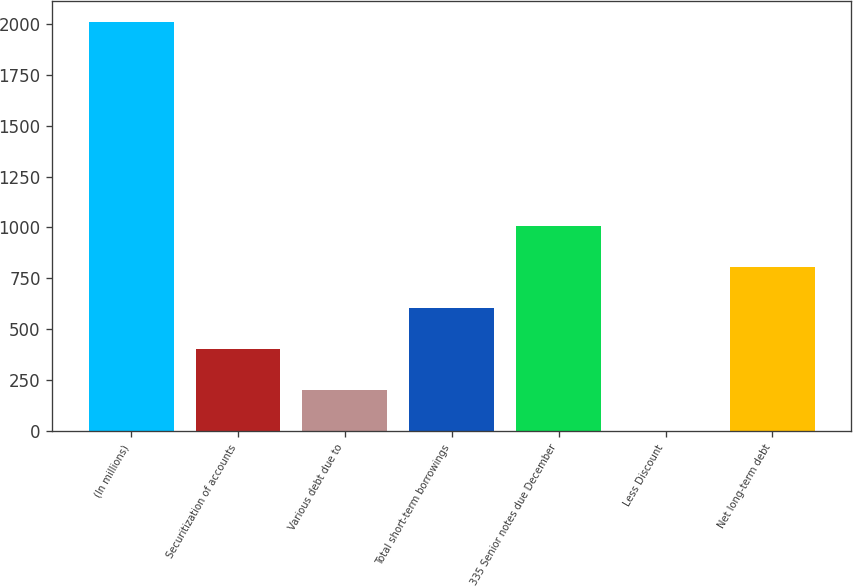<chart> <loc_0><loc_0><loc_500><loc_500><bar_chart><fcel>(In millions)<fcel>Securitization of accounts<fcel>Various debt due to<fcel>Total short-term borrowings<fcel>335 Senior notes due December<fcel>Less Discount<fcel>Net long-term debt<nl><fcel>2010<fcel>402.24<fcel>201.27<fcel>603.21<fcel>1005.15<fcel>0.3<fcel>804.18<nl></chart> 